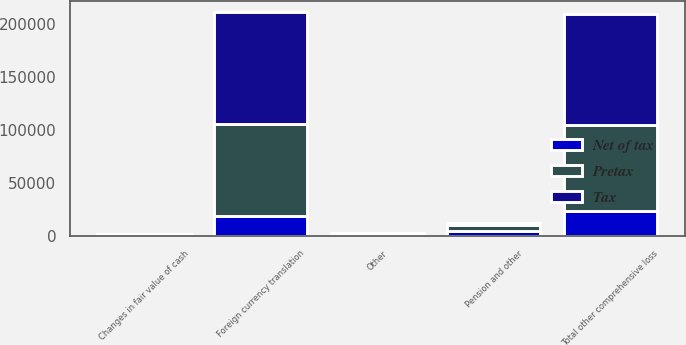Convert chart. <chart><loc_0><loc_0><loc_500><loc_500><stacked_bar_chart><ecel><fcel>Foreign currency translation<fcel>Pension and other<fcel>Changes in fair value of cash<fcel>Other<fcel>Total other comprehensive loss<nl><fcel>Pretax<fcel>86876<fcel>5936<fcel>860<fcel>1119<fcel>81199<nl><fcel>Net of tax<fcel>18827<fcel>4560<fcel>301<fcel>134<fcel>23554<nl><fcel>Tax<fcel>105703<fcel>1376<fcel>559<fcel>985<fcel>104753<nl></chart> 